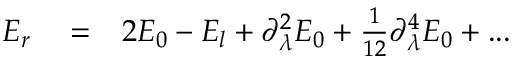Convert formula to latex. <formula><loc_0><loc_0><loc_500><loc_500>\begin{array} { r l r } { E _ { r } } & = } & { 2 E _ { 0 } - E _ { l } + \partial _ { \lambda } ^ { 2 } E _ { 0 } + \frac { 1 } { 1 2 } \partial _ { \lambda } ^ { 4 } E _ { 0 } + \dots } \end{array}</formula> 